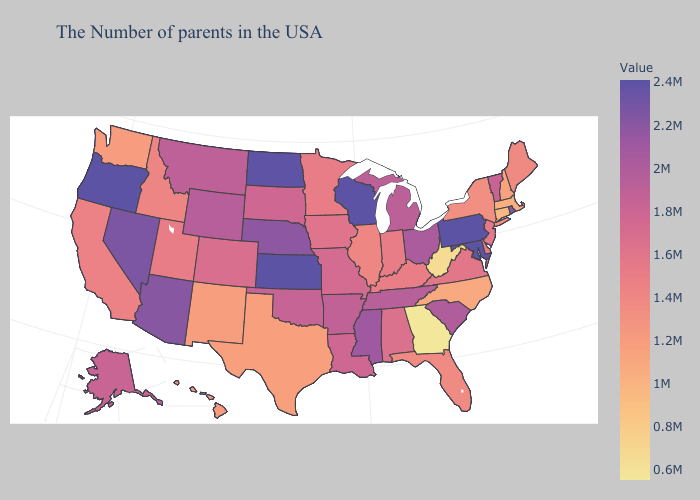Which states have the highest value in the USA?
Concise answer only. Maryland, Pennsylvania, Wisconsin, Kansas, Oregon. Does Nevada have the lowest value in the USA?
Concise answer only. No. Among the states that border Washington , does Oregon have the lowest value?
Answer briefly. No. Among the states that border Louisiana , does Arkansas have the lowest value?
Short answer required. No. Does Georgia have the lowest value in the USA?
Quick response, please. Yes. Does Rhode Island have the lowest value in the Northeast?
Write a very short answer. No. Does New Hampshire have a higher value than Nevada?
Answer briefly. No. 